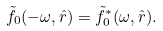<formula> <loc_0><loc_0><loc_500><loc_500>\tilde { f } _ { 0 } ( - \omega , \hat { r } ) = \tilde { f } _ { 0 } ^ { * } ( \omega , \hat { r } ) .</formula> 